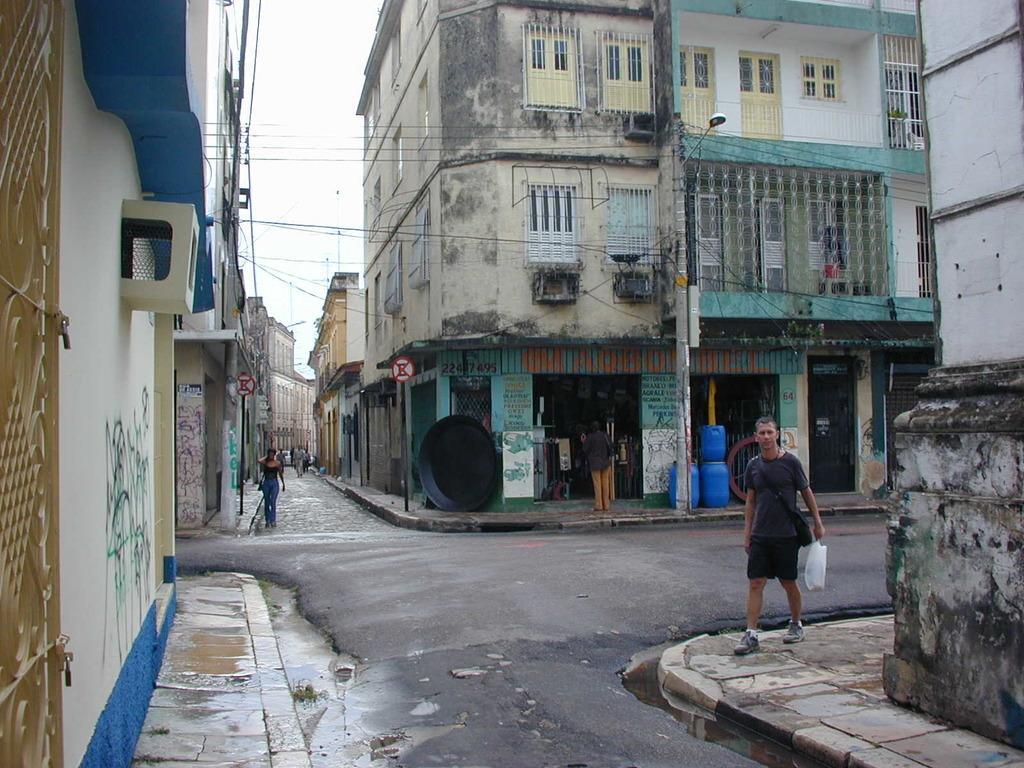Describe this image in one or two sentences. In the picture I can see people walking on the ground. In the background I can see wires, street lights, buildings, the sky, blue color objects and some other objects. 